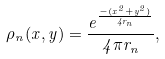Convert formula to latex. <formula><loc_0><loc_0><loc_500><loc_500>\rho _ { n } ( x , y ) = \frac { e ^ { \frac { - ( x ^ { 2 } + y ^ { 2 } ) } { 4 r _ { n } } } } { 4 \pi r _ { n } } ,</formula> 